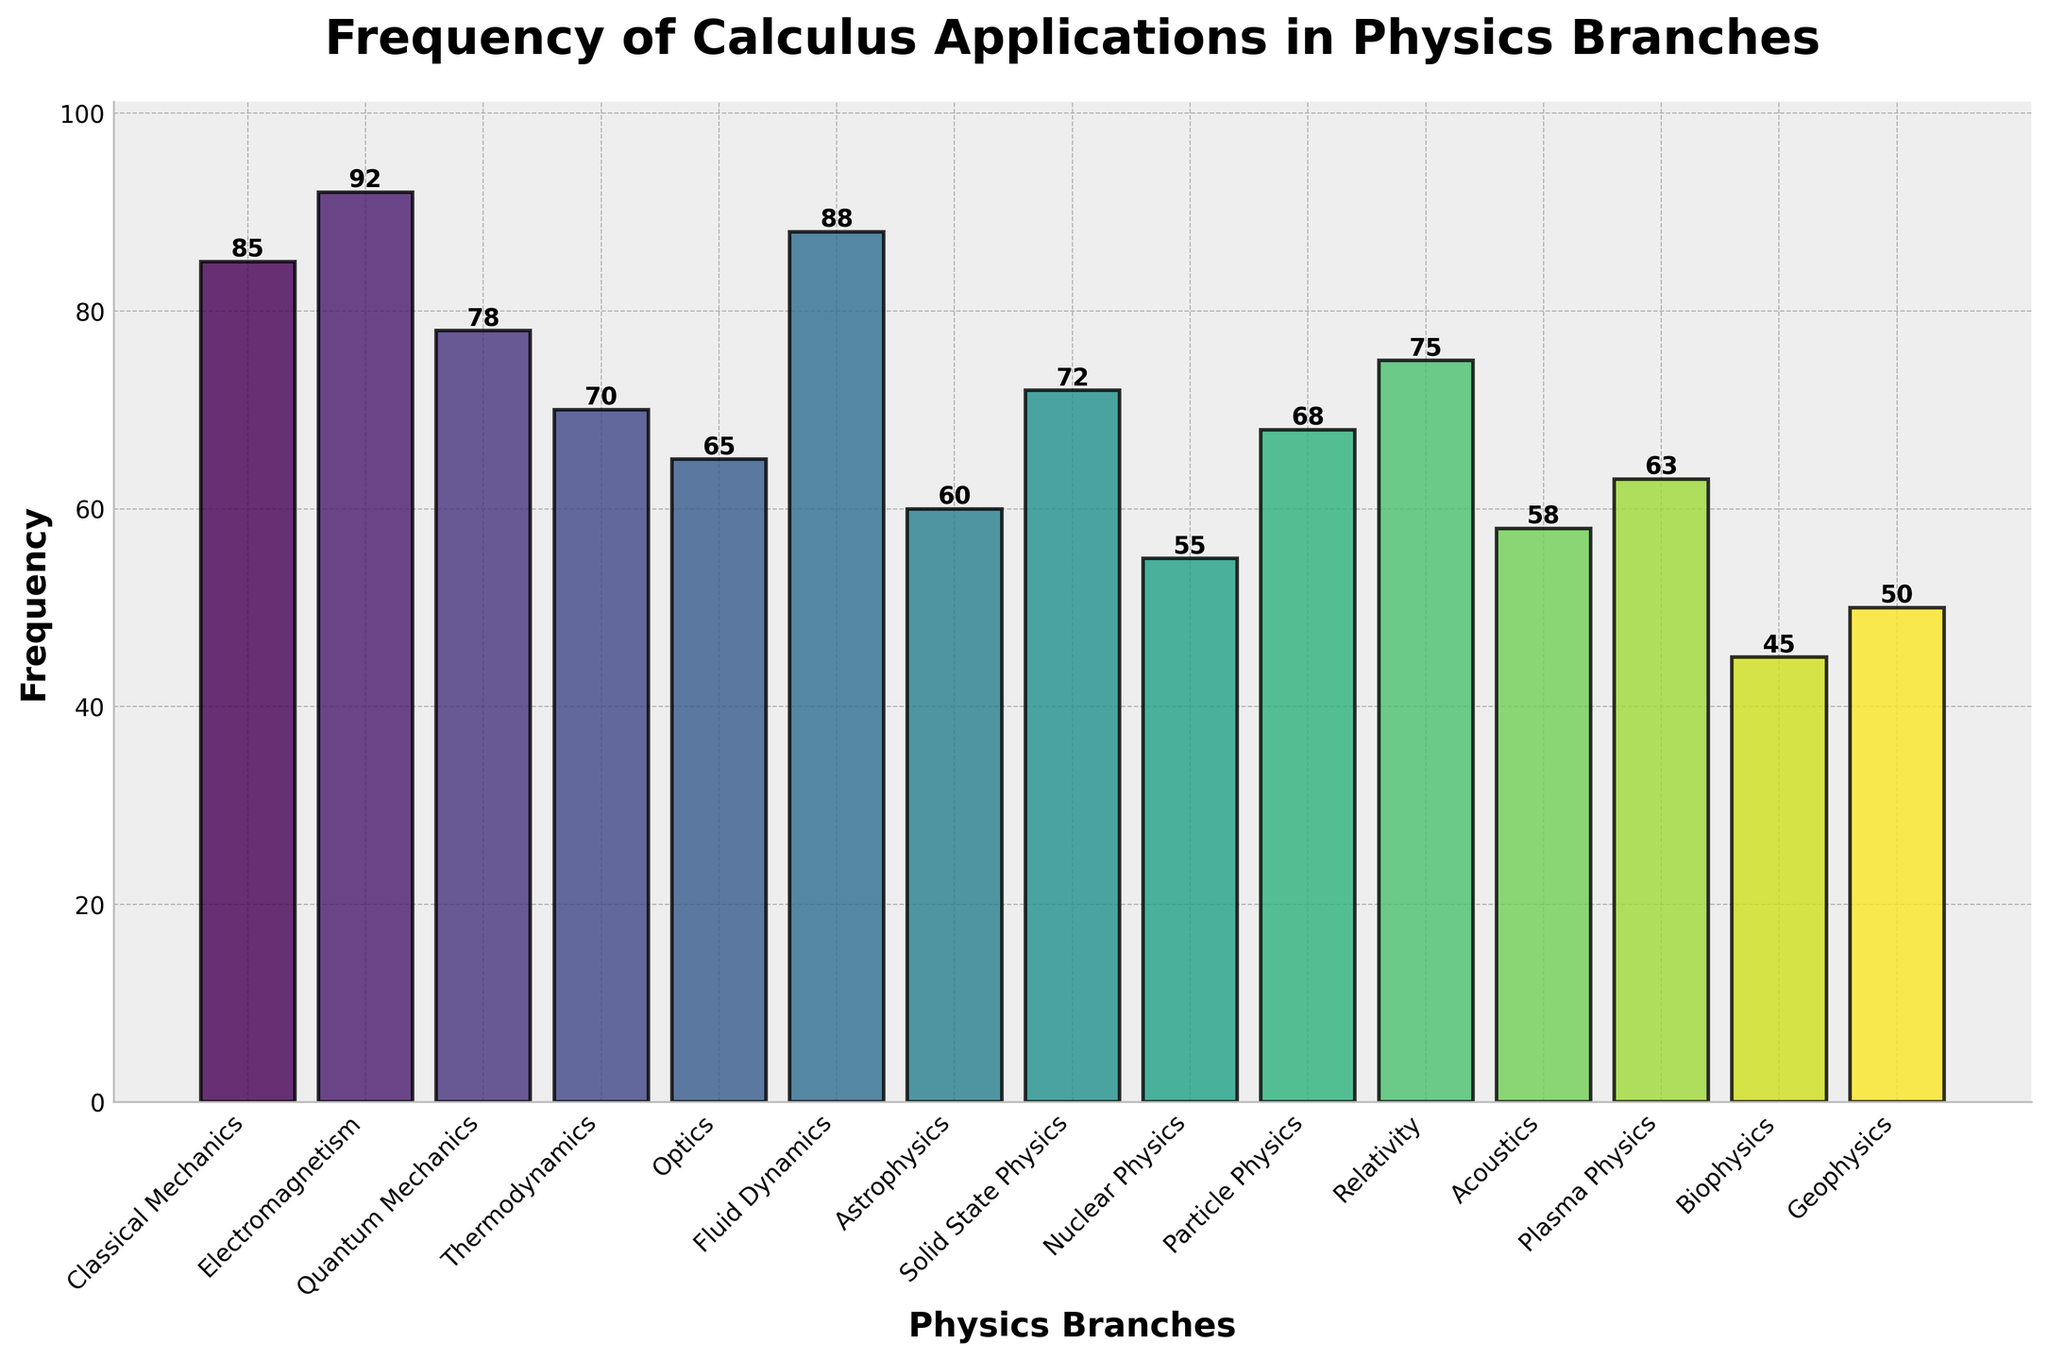What's the branch with the highest frequency of calculus applications? The branch with the highest bar represents the branch with the highest frequency. In the figure, the highest bar corresponds to Electromagnetism.
Answer: Electromagnetism Which branch has the lowest frequency of calculus applications? The branch with the shortest bar represents the branch with the lowest frequency. In the figure, the shortest bar corresponds to Biophysics.
Answer: Biophysics How much higher is the frequency of calculus applications in Electromagnetism compared to Nuclear Physics? Identify the frequency for Electromagnetism and Nuclear Physics from the bar heights. Electromagnetism has a frequency of 92, and Nuclear Physics has a frequency of 55. Calculate the difference: 92 - 55.
Answer: 37 What is the average frequency of calculus applications in Classical Mechanics, Fluid Dynamics, and Relativity? Identify the frequency for each branch: Classical Mechanics (85), Fluid Dynamics (88), and Relativity (75). Sum these values and divide by the number of branches: (85 + 88 + 75) / 3.
Answer: 82.67 How does the frequency of calculus applications in Quantum Mechanics compare to that in Thermodynamics? Compare the heights of the bars for Quantum Mechanics and Thermodynamics. Quantum Mechanics has a frequency of 78, and Thermodynamics has a frequency of 70.
Answer: Quantum Mechanics is higher by 8 Which three branches with the highest frequencies form an increasing sequence of heights of the bars? Identify the three branches with the highest frequencies: Electromagnetism (92), Fluid Dynamics (88), and Classical Mechanics (85). Arrange them in ascending order of frequency.
Answer: Classical Mechanics, Fluid Dynamics, Electromagnetism Between Optics and Plasma Physics, which has a higher frequency of calculus applications and by how much? Identify the frequencies from the bar heights: Optics (65) and Plasma Physics (63). Calculate the difference: 65 - 63.
Answer: Optics by 2 What is the total frequency of calculus applications across the branches Astrophysics, Solid State Physics, and Acoustics? Identify the frequencies for each branch: Astrophysics (60), Solid State Physics (72), and Acoustics (58). Sum these values: 60 + 72 + 58.
Answer: 190 Compare the frequency of calculus applications between Thermodynamics and Particle Physics. Which one is higher and by how much? Identify the frequencies: Thermodynamics (70) and Particle Physics (68). Calculate the difference: 70 - 68.
Answer: Thermodynamics by 2 What is the range of frequencies in the figure? Identify the highest frequency (Electromagnetism, 92) and the lowest frequency (Biophysics, 45). Calculate the range: 92 - 45.
Answer: 47 